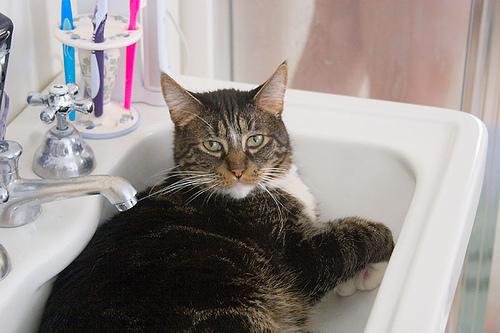Should the cat be there?
Give a very brief answer. No. Is the cat getting wet?
Write a very short answer. No. How many toothbrushes are visible?
Answer briefly. 3. What color is the cup on the sink?
Short answer required. White. What color is the cat?
Keep it brief. Brown. 